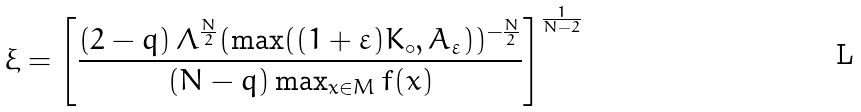<formula> <loc_0><loc_0><loc_500><loc_500>\xi = \left [ \frac { \left ( 2 - q \right ) \Lambda ^ { \frac { N } { 2 } } ( \max ( ( 1 + \varepsilon ) K _ { \circ } , A _ { \varepsilon } ) ) ^ { - \frac { N } { 2 } } } { \left ( N - q \right ) \max _ { x \in M } f ( x ) } \right ] ^ { \frac { 1 } { N - 2 } }</formula> 